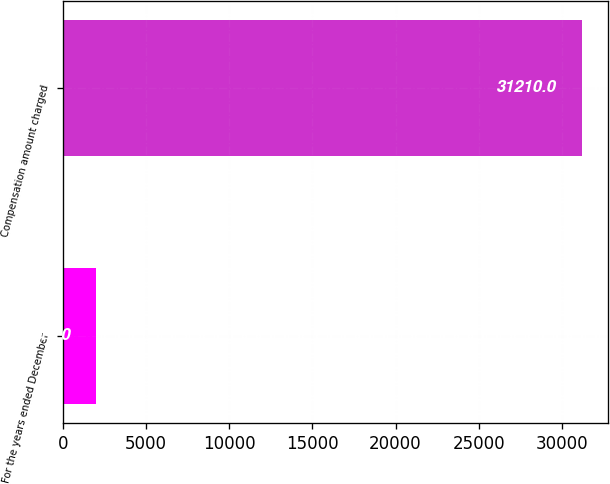Convert chart to OTSL. <chart><loc_0><loc_0><loc_500><loc_500><bar_chart><fcel>For the years ended December<fcel>Compensation amount charged<nl><fcel>2012<fcel>31210<nl></chart> 